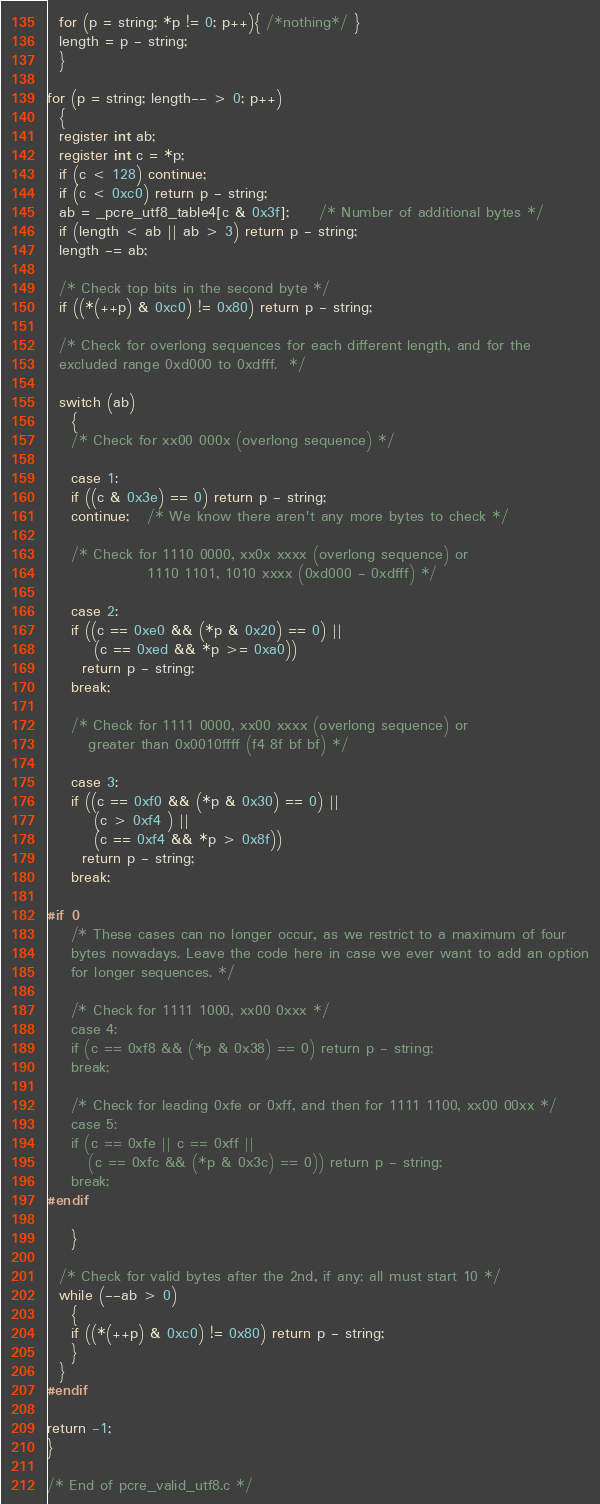Convert code to text. <code><loc_0><loc_0><loc_500><loc_500><_C++_>  for (p = string; *p != 0; p++){ /*nothing*/ }
  length = p - string;
  }

for (p = string; length-- > 0; p++)
  {
  register int ab;
  register int c = *p;
  if (c < 128) continue;
  if (c < 0xc0) return p - string;
  ab = _pcre_utf8_table4[c & 0x3f];     /* Number of additional bytes */
  if (length < ab || ab > 3) return p - string;
  length -= ab;

  /* Check top bits in the second byte */
  if ((*(++p) & 0xc0) != 0x80) return p - string;

  /* Check for overlong sequences for each different length, and for the
  excluded range 0xd000 to 0xdfff.  */

  switch (ab)
    {
    /* Check for xx00 000x (overlong sequence) */

    case 1:
    if ((c & 0x3e) == 0) return p - string;
    continue;   /* We know there aren't any more bytes to check */

    /* Check for 1110 0000, xx0x xxxx (overlong sequence) or
                 1110 1101, 1010 xxxx (0xd000 - 0xdfff) */

    case 2:
    if ((c == 0xe0 && (*p & 0x20) == 0) ||
        (c == 0xed && *p >= 0xa0))
      return p - string;
    break;

    /* Check for 1111 0000, xx00 xxxx (overlong sequence) or
       greater than 0x0010ffff (f4 8f bf bf) */

    case 3:
    if ((c == 0xf0 && (*p & 0x30) == 0) ||
        (c > 0xf4 ) ||
        (c == 0xf4 && *p > 0x8f))
      return p - string;
    break;

#if 0
    /* These cases can no longer occur, as we restrict to a maximum of four
    bytes nowadays. Leave the code here in case we ever want to add an option
    for longer sequences. */

    /* Check for 1111 1000, xx00 0xxx */
    case 4:
    if (c == 0xf8 && (*p & 0x38) == 0) return p - string;
    break;

    /* Check for leading 0xfe or 0xff, and then for 1111 1100, xx00 00xx */
    case 5:
    if (c == 0xfe || c == 0xff ||
       (c == 0xfc && (*p & 0x3c) == 0)) return p - string;
    break;
#endif

    }

  /* Check for valid bytes after the 2nd, if any; all must start 10 */
  while (--ab > 0)
    {
    if ((*(++p) & 0xc0) != 0x80) return p - string;
    }
  }
#endif

return -1;
}

/* End of pcre_valid_utf8.c */
</code> 